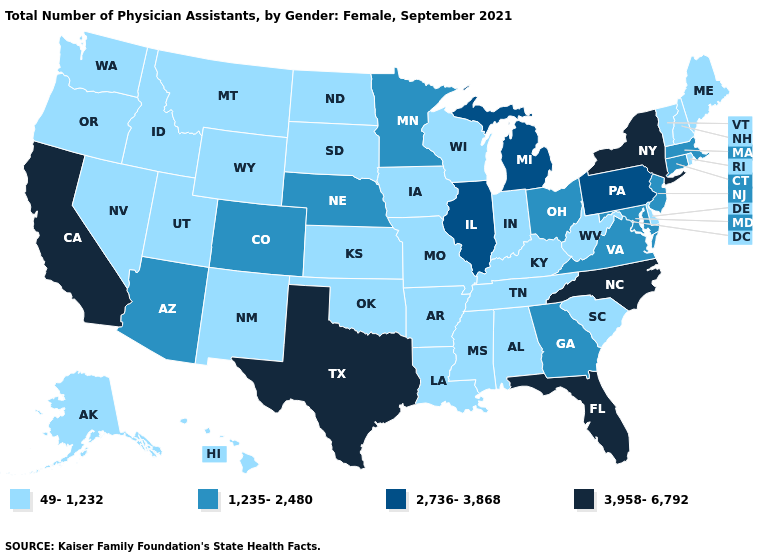Name the states that have a value in the range 2,736-3,868?
Quick response, please. Illinois, Michigan, Pennsylvania. Name the states that have a value in the range 2,736-3,868?
Write a very short answer. Illinois, Michigan, Pennsylvania. Name the states that have a value in the range 2,736-3,868?
Quick response, please. Illinois, Michigan, Pennsylvania. What is the lowest value in states that border Arkansas?
Give a very brief answer. 49-1,232. What is the value of Maine?
Write a very short answer. 49-1,232. What is the highest value in the West ?
Answer briefly. 3,958-6,792. Which states have the lowest value in the South?
Write a very short answer. Alabama, Arkansas, Delaware, Kentucky, Louisiana, Mississippi, Oklahoma, South Carolina, Tennessee, West Virginia. Does the first symbol in the legend represent the smallest category?
Give a very brief answer. Yes. Name the states that have a value in the range 3,958-6,792?
Concise answer only. California, Florida, New York, North Carolina, Texas. Which states have the lowest value in the Northeast?
Short answer required. Maine, New Hampshire, Rhode Island, Vermont. What is the value of New Hampshire?
Answer briefly. 49-1,232. Name the states that have a value in the range 49-1,232?
Answer briefly. Alabama, Alaska, Arkansas, Delaware, Hawaii, Idaho, Indiana, Iowa, Kansas, Kentucky, Louisiana, Maine, Mississippi, Missouri, Montana, Nevada, New Hampshire, New Mexico, North Dakota, Oklahoma, Oregon, Rhode Island, South Carolina, South Dakota, Tennessee, Utah, Vermont, Washington, West Virginia, Wisconsin, Wyoming. What is the value of Maryland?
Quick response, please. 1,235-2,480. Does the first symbol in the legend represent the smallest category?
Short answer required. Yes. What is the value of North Carolina?
Write a very short answer. 3,958-6,792. 